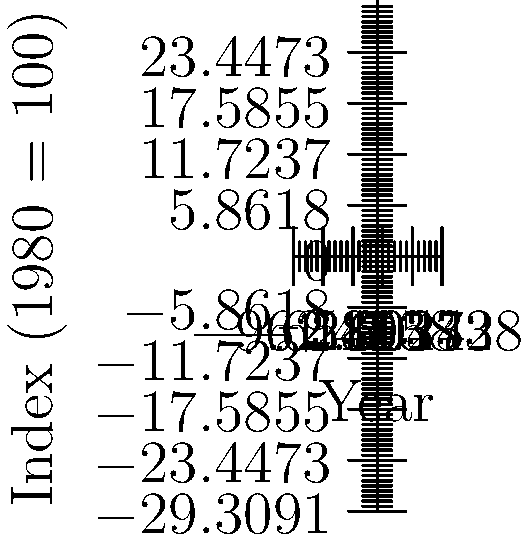As a union member, you're analyzing the relationship between worker productivity and wages over time. The graph shows productivity and wage indices from 1980 to 2020, with 1980 as the base year (index = 100). What is the percentage difference between productivity growth and wage growth from 1980 to 2020? To solve this problem, we'll follow these steps:

1. Identify the productivity and wage indices for 2020:
   Productivity in 2020: 155
   Wages in 2020: 95

2. Calculate the growth rate for each:
   Productivity growth = $(155 - 100) / 100 \times 100\% = 55\%$
   Wage growth = $(95 - 100) / 100 \times 100\% = -5\%$

3. Calculate the difference between the two growth rates:
   Difference = Productivity growth - Wage growth
               = $55\% - (-5\%) = 55\% + 5\% = 60\%$

The percentage difference between productivity growth and wage growth from 1980 to 2020 is 60%.

This significant gap between productivity and wage growth is often referred to as the "productivity-pay gap" and is a common concern for labor unions, as it suggests that workers are not fully benefiting from their increased productivity.
Answer: 60% 